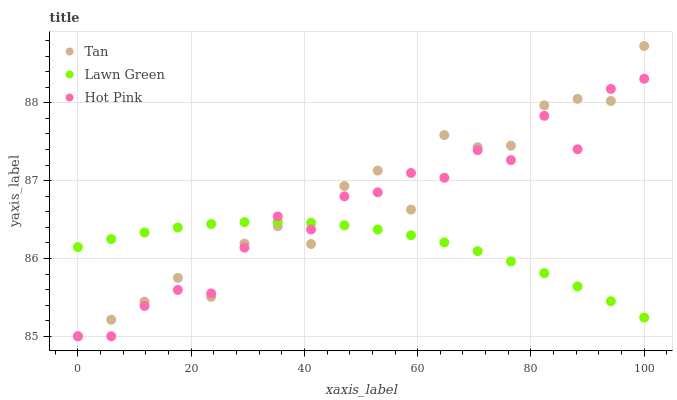Does Lawn Green have the minimum area under the curve?
Answer yes or no. Yes. Does Tan have the maximum area under the curve?
Answer yes or no. Yes. Does Hot Pink have the minimum area under the curve?
Answer yes or no. No. Does Hot Pink have the maximum area under the curve?
Answer yes or no. No. Is Lawn Green the smoothest?
Answer yes or no. Yes. Is Tan the roughest?
Answer yes or no. Yes. Is Hot Pink the smoothest?
Answer yes or no. No. Is Hot Pink the roughest?
Answer yes or no. No. Does Tan have the lowest value?
Answer yes or no. Yes. Does Tan have the highest value?
Answer yes or no. Yes. Does Hot Pink have the highest value?
Answer yes or no. No. Does Hot Pink intersect Tan?
Answer yes or no. Yes. Is Hot Pink less than Tan?
Answer yes or no. No. Is Hot Pink greater than Tan?
Answer yes or no. No. 